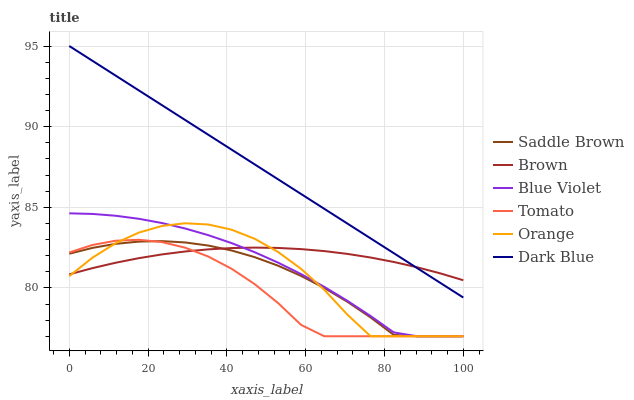Does Tomato have the minimum area under the curve?
Answer yes or no. Yes. Does Dark Blue have the maximum area under the curve?
Answer yes or no. Yes. Does Brown have the minimum area under the curve?
Answer yes or no. No. Does Brown have the maximum area under the curve?
Answer yes or no. No. Is Dark Blue the smoothest?
Answer yes or no. Yes. Is Orange the roughest?
Answer yes or no. Yes. Is Brown the smoothest?
Answer yes or no. No. Is Brown the roughest?
Answer yes or no. No. Does Tomato have the lowest value?
Answer yes or no. Yes. Does Dark Blue have the lowest value?
Answer yes or no. No. Does Dark Blue have the highest value?
Answer yes or no. Yes. Does Brown have the highest value?
Answer yes or no. No. Is Tomato less than Dark Blue?
Answer yes or no. Yes. Is Dark Blue greater than Blue Violet?
Answer yes or no. Yes. Does Blue Violet intersect Saddle Brown?
Answer yes or no. Yes. Is Blue Violet less than Saddle Brown?
Answer yes or no. No. Is Blue Violet greater than Saddle Brown?
Answer yes or no. No. Does Tomato intersect Dark Blue?
Answer yes or no. No. 